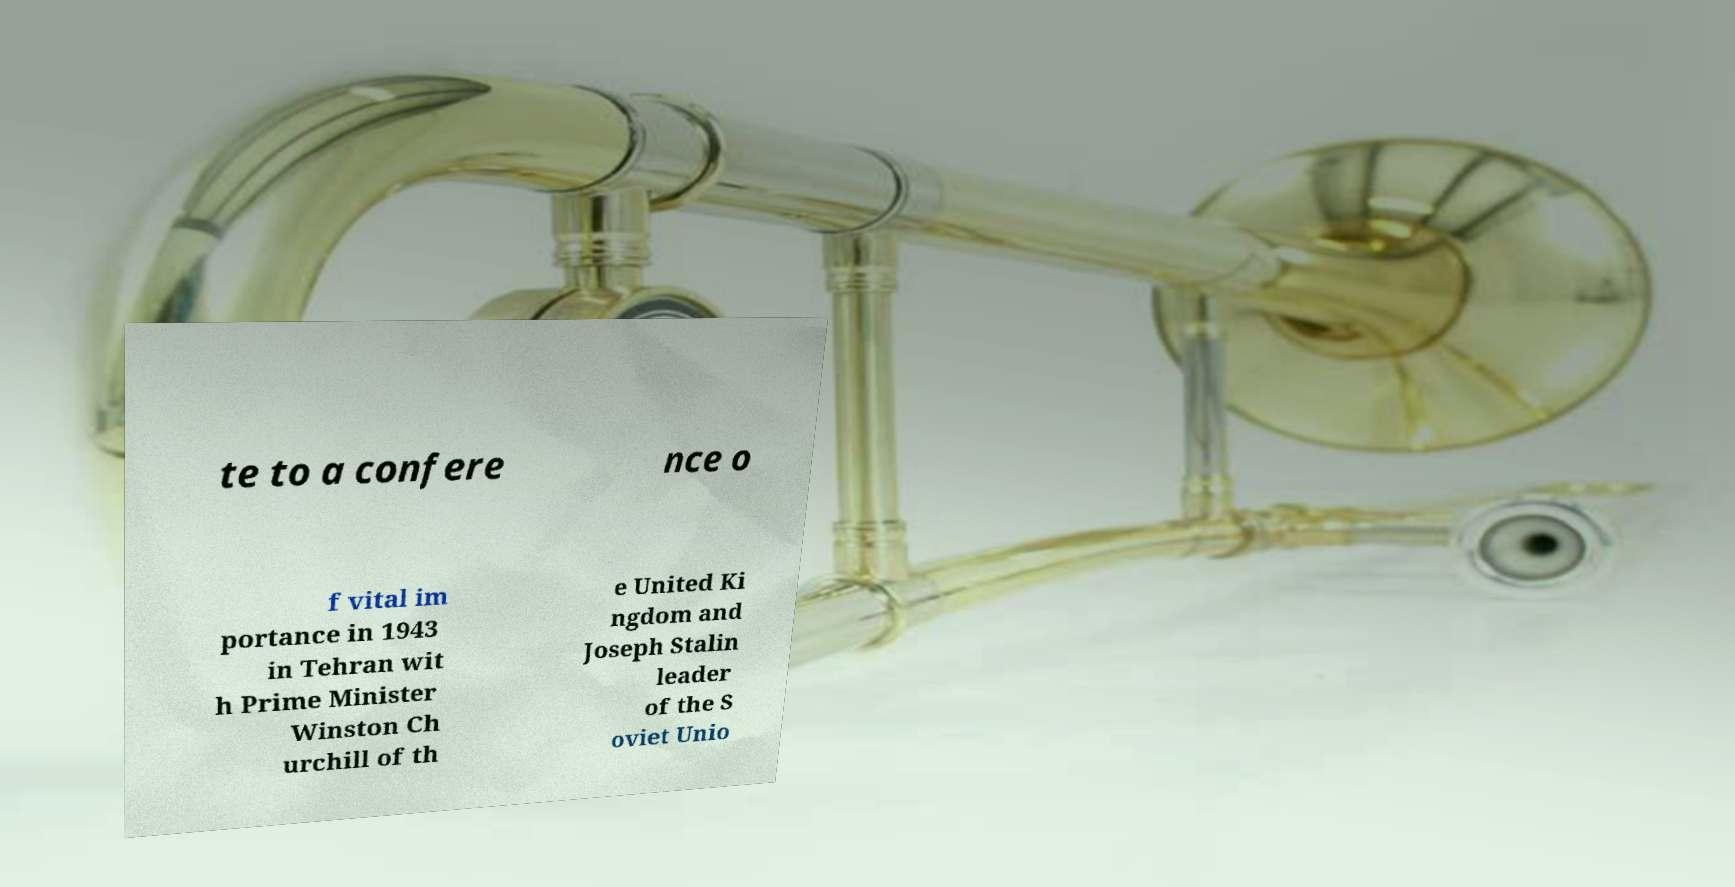There's text embedded in this image that I need extracted. Can you transcribe it verbatim? te to a confere nce o f vital im portance in 1943 in Tehran wit h Prime Minister Winston Ch urchill of th e United Ki ngdom and Joseph Stalin leader of the S oviet Unio 